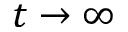Convert formula to latex. <formula><loc_0><loc_0><loc_500><loc_500>t \rightarrow \infty</formula> 